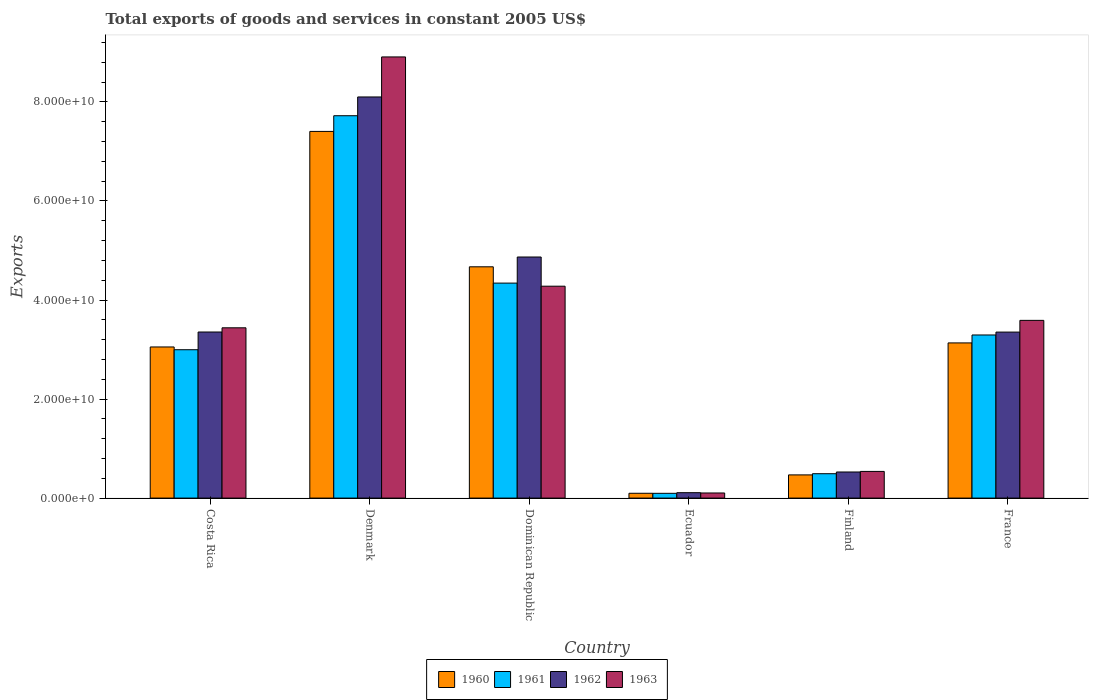How many different coloured bars are there?
Provide a short and direct response. 4. How many groups of bars are there?
Make the answer very short. 6. Are the number of bars per tick equal to the number of legend labels?
Keep it short and to the point. Yes. Are the number of bars on each tick of the X-axis equal?
Offer a very short reply. Yes. How many bars are there on the 4th tick from the left?
Ensure brevity in your answer.  4. What is the label of the 4th group of bars from the left?
Your answer should be very brief. Ecuador. In how many cases, is the number of bars for a given country not equal to the number of legend labels?
Your answer should be very brief. 0. What is the total exports of goods and services in 1963 in Dominican Republic?
Keep it short and to the point. 4.28e+1. Across all countries, what is the maximum total exports of goods and services in 1963?
Your answer should be very brief. 8.91e+1. Across all countries, what is the minimum total exports of goods and services in 1961?
Give a very brief answer. 9.65e+08. In which country was the total exports of goods and services in 1961 maximum?
Provide a short and direct response. Denmark. In which country was the total exports of goods and services in 1960 minimum?
Your response must be concise. Ecuador. What is the total total exports of goods and services in 1962 in the graph?
Keep it short and to the point. 2.03e+11. What is the difference between the total exports of goods and services in 1963 in Costa Rica and that in Denmark?
Make the answer very short. -5.47e+1. What is the difference between the total exports of goods and services in 1962 in Ecuador and the total exports of goods and services in 1963 in France?
Your answer should be very brief. -3.48e+1. What is the average total exports of goods and services in 1960 per country?
Provide a short and direct response. 3.14e+1. What is the difference between the total exports of goods and services of/in 1961 and total exports of goods and services of/in 1962 in Dominican Republic?
Ensure brevity in your answer.  -5.27e+09. What is the ratio of the total exports of goods and services in 1963 in Costa Rica to that in Finland?
Make the answer very short. 6.38. Is the difference between the total exports of goods and services in 1961 in Costa Rica and Denmark greater than the difference between the total exports of goods and services in 1962 in Costa Rica and Denmark?
Offer a very short reply. Yes. What is the difference between the highest and the second highest total exports of goods and services in 1960?
Provide a short and direct response. -2.73e+1. What is the difference between the highest and the lowest total exports of goods and services in 1963?
Ensure brevity in your answer.  8.81e+1. Is it the case that in every country, the sum of the total exports of goods and services in 1961 and total exports of goods and services in 1963 is greater than the sum of total exports of goods and services in 1960 and total exports of goods and services in 1962?
Your answer should be very brief. No. What does the 4th bar from the left in Finland represents?
Provide a succinct answer. 1963. Is it the case that in every country, the sum of the total exports of goods and services in 1962 and total exports of goods and services in 1961 is greater than the total exports of goods and services in 1960?
Ensure brevity in your answer.  Yes. Does the graph contain grids?
Ensure brevity in your answer.  No. How are the legend labels stacked?
Your answer should be compact. Horizontal. What is the title of the graph?
Make the answer very short. Total exports of goods and services in constant 2005 US$. Does "1962" appear as one of the legend labels in the graph?
Your response must be concise. Yes. What is the label or title of the Y-axis?
Provide a succinct answer. Exports. What is the Exports of 1960 in Costa Rica?
Make the answer very short. 3.05e+1. What is the Exports of 1961 in Costa Rica?
Offer a very short reply. 3.00e+1. What is the Exports in 1962 in Costa Rica?
Provide a short and direct response. 3.35e+1. What is the Exports of 1963 in Costa Rica?
Keep it short and to the point. 3.44e+1. What is the Exports of 1960 in Denmark?
Offer a terse response. 7.40e+1. What is the Exports in 1961 in Denmark?
Give a very brief answer. 7.72e+1. What is the Exports of 1962 in Denmark?
Provide a succinct answer. 8.10e+1. What is the Exports in 1963 in Denmark?
Keep it short and to the point. 8.91e+1. What is the Exports in 1960 in Dominican Republic?
Provide a succinct answer. 4.67e+1. What is the Exports in 1961 in Dominican Republic?
Keep it short and to the point. 4.34e+1. What is the Exports in 1962 in Dominican Republic?
Your answer should be compact. 4.87e+1. What is the Exports in 1963 in Dominican Republic?
Make the answer very short. 4.28e+1. What is the Exports of 1960 in Ecuador?
Keep it short and to the point. 9.72e+08. What is the Exports of 1961 in Ecuador?
Your answer should be compact. 9.65e+08. What is the Exports in 1962 in Ecuador?
Your answer should be very brief. 1.09e+09. What is the Exports of 1963 in Ecuador?
Your answer should be compact. 1.03e+09. What is the Exports of 1960 in Finland?
Give a very brief answer. 4.68e+09. What is the Exports in 1961 in Finland?
Your response must be concise. 4.92e+09. What is the Exports of 1962 in Finland?
Provide a short and direct response. 5.27e+09. What is the Exports of 1963 in Finland?
Make the answer very short. 5.39e+09. What is the Exports in 1960 in France?
Your answer should be very brief. 3.13e+1. What is the Exports of 1961 in France?
Your answer should be compact. 3.29e+1. What is the Exports in 1962 in France?
Make the answer very short. 3.35e+1. What is the Exports of 1963 in France?
Provide a succinct answer. 3.59e+1. Across all countries, what is the maximum Exports in 1960?
Make the answer very short. 7.40e+1. Across all countries, what is the maximum Exports of 1961?
Your answer should be very brief. 7.72e+1. Across all countries, what is the maximum Exports of 1962?
Your response must be concise. 8.10e+1. Across all countries, what is the maximum Exports of 1963?
Provide a short and direct response. 8.91e+1. Across all countries, what is the minimum Exports of 1960?
Offer a terse response. 9.72e+08. Across all countries, what is the minimum Exports of 1961?
Make the answer very short. 9.65e+08. Across all countries, what is the minimum Exports in 1962?
Make the answer very short. 1.09e+09. Across all countries, what is the minimum Exports in 1963?
Your answer should be compact. 1.03e+09. What is the total Exports in 1960 in the graph?
Offer a very short reply. 1.88e+11. What is the total Exports in 1961 in the graph?
Give a very brief answer. 1.89e+11. What is the total Exports of 1962 in the graph?
Offer a terse response. 2.03e+11. What is the total Exports of 1963 in the graph?
Keep it short and to the point. 2.09e+11. What is the difference between the Exports in 1960 in Costa Rica and that in Denmark?
Offer a very short reply. -4.35e+1. What is the difference between the Exports in 1961 in Costa Rica and that in Denmark?
Offer a very short reply. -4.73e+1. What is the difference between the Exports of 1962 in Costa Rica and that in Denmark?
Offer a terse response. -4.75e+1. What is the difference between the Exports in 1963 in Costa Rica and that in Denmark?
Give a very brief answer. -5.47e+1. What is the difference between the Exports in 1960 in Costa Rica and that in Dominican Republic?
Make the answer very short. -1.62e+1. What is the difference between the Exports in 1961 in Costa Rica and that in Dominican Republic?
Your answer should be very brief. -1.35e+1. What is the difference between the Exports of 1962 in Costa Rica and that in Dominican Republic?
Offer a terse response. -1.51e+1. What is the difference between the Exports in 1963 in Costa Rica and that in Dominican Republic?
Make the answer very short. -8.40e+09. What is the difference between the Exports in 1960 in Costa Rica and that in Ecuador?
Provide a short and direct response. 2.95e+1. What is the difference between the Exports of 1961 in Costa Rica and that in Ecuador?
Give a very brief answer. 2.90e+1. What is the difference between the Exports of 1962 in Costa Rica and that in Ecuador?
Your response must be concise. 3.24e+1. What is the difference between the Exports in 1963 in Costa Rica and that in Ecuador?
Your answer should be compact. 3.34e+1. What is the difference between the Exports of 1960 in Costa Rica and that in Finland?
Your answer should be compact. 2.58e+1. What is the difference between the Exports of 1961 in Costa Rica and that in Finland?
Ensure brevity in your answer.  2.50e+1. What is the difference between the Exports of 1962 in Costa Rica and that in Finland?
Give a very brief answer. 2.83e+1. What is the difference between the Exports of 1963 in Costa Rica and that in Finland?
Offer a very short reply. 2.90e+1. What is the difference between the Exports in 1960 in Costa Rica and that in France?
Give a very brief answer. -8.16e+08. What is the difference between the Exports in 1961 in Costa Rica and that in France?
Your answer should be very brief. -2.98e+09. What is the difference between the Exports in 1962 in Costa Rica and that in France?
Keep it short and to the point. 1.76e+07. What is the difference between the Exports of 1963 in Costa Rica and that in France?
Offer a terse response. -1.50e+09. What is the difference between the Exports in 1960 in Denmark and that in Dominican Republic?
Your answer should be very brief. 2.73e+1. What is the difference between the Exports in 1961 in Denmark and that in Dominican Republic?
Your response must be concise. 3.38e+1. What is the difference between the Exports in 1962 in Denmark and that in Dominican Republic?
Provide a short and direct response. 3.23e+1. What is the difference between the Exports of 1963 in Denmark and that in Dominican Republic?
Provide a short and direct response. 4.63e+1. What is the difference between the Exports in 1960 in Denmark and that in Ecuador?
Offer a very short reply. 7.31e+1. What is the difference between the Exports of 1961 in Denmark and that in Ecuador?
Provide a succinct answer. 7.62e+1. What is the difference between the Exports in 1962 in Denmark and that in Ecuador?
Make the answer very short. 7.99e+1. What is the difference between the Exports in 1963 in Denmark and that in Ecuador?
Offer a terse response. 8.81e+1. What is the difference between the Exports of 1960 in Denmark and that in Finland?
Offer a terse response. 6.94e+1. What is the difference between the Exports in 1961 in Denmark and that in Finland?
Your answer should be compact. 7.23e+1. What is the difference between the Exports of 1962 in Denmark and that in Finland?
Your answer should be compact. 7.57e+1. What is the difference between the Exports of 1963 in Denmark and that in Finland?
Offer a terse response. 8.37e+1. What is the difference between the Exports in 1960 in Denmark and that in France?
Your response must be concise. 4.27e+1. What is the difference between the Exports in 1961 in Denmark and that in France?
Make the answer very short. 4.43e+1. What is the difference between the Exports of 1962 in Denmark and that in France?
Your answer should be very brief. 4.75e+1. What is the difference between the Exports in 1963 in Denmark and that in France?
Your answer should be very brief. 5.32e+1. What is the difference between the Exports of 1960 in Dominican Republic and that in Ecuador?
Your answer should be compact. 4.57e+1. What is the difference between the Exports in 1961 in Dominican Republic and that in Ecuador?
Offer a terse response. 4.25e+1. What is the difference between the Exports of 1962 in Dominican Republic and that in Ecuador?
Make the answer very short. 4.76e+1. What is the difference between the Exports in 1963 in Dominican Republic and that in Ecuador?
Your response must be concise. 4.18e+1. What is the difference between the Exports in 1960 in Dominican Republic and that in Finland?
Provide a succinct answer. 4.20e+1. What is the difference between the Exports of 1961 in Dominican Republic and that in Finland?
Make the answer very short. 3.85e+1. What is the difference between the Exports in 1962 in Dominican Republic and that in Finland?
Your answer should be very brief. 4.34e+1. What is the difference between the Exports of 1963 in Dominican Republic and that in Finland?
Give a very brief answer. 3.74e+1. What is the difference between the Exports of 1960 in Dominican Republic and that in France?
Provide a succinct answer. 1.54e+1. What is the difference between the Exports of 1961 in Dominican Republic and that in France?
Your answer should be very brief. 1.05e+1. What is the difference between the Exports in 1962 in Dominican Republic and that in France?
Make the answer very short. 1.52e+1. What is the difference between the Exports in 1963 in Dominican Republic and that in France?
Provide a succinct answer. 6.90e+09. What is the difference between the Exports in 1960 in Ecuador and that in Finland?
Offer a very short reply. -3.71e+09. What is the difference between the Exports of 1961 in Ecuador and that in Finland?
Make the answer very short. -3.96e+09. What is the difference between the Exports of 1962 in Ecuador and that in Finland?
Your response must be concise. -4.18e+09. What is the difference between the Exports of 1963 in Ecuador and that in Finland?
Offer a very short reply. -4.36e+09. What is the difference between the Exports of 1960 in Ecuador and that in France?
Your response must be concise. -3.04e+1. What is the difference between the Exports in 1961 in Ecuador and that in France?
Your answer should be compact. -3.20e+1. What is the difference between the Exports in 1962 in Ecuador and that in France?
Ensure brevity in your answer.  -3.24e+1. What is the difference between the Exports of 1963 in Ecuador and that in France?
Provide a short and direct response. -3.49e+1. What is the difference between the Exports of 1960 in Finland and that in France?
Ensure brevity in your answer.  -2.67e+1. What is the difference between the Exports in 1961 in Finland and that in France?
Provide a short and direct response. -2.80e+1. What is the difference between the Exports of 1962 in Finland and that in France?
Keep it short and to the point. -2.83e+1. What is the difference between the Exports in 1963 in Finland and that in France?
Keep it short and to the point. -3.05e+1. What is the difference between the Exports in 1960 in Costa Rica and the Exports in 1961 in Denmark?
Offer a very short reply. -4.67e+1. What is the difference between the Exports in 1960 in Costa Rica and the Exports in 1962 in Denmark?
Keep it short and to the point. -5.05e+1. What is the difference between the Exports of 1960 in Costa Rica and the Exports of 1963 in Denmark?
Your answer should be compact. -5.86e+1. What is the difference between the Exports in 1961 in Costa Rica and the Exports in 1962 in Denmark?
Keep it short and to the point. -5.10e+1. What is the difference between the Exports of 1961 in Costa Rica and the Exports of 1963 in Denmark?
Give a very brief answer. -5.91e+1. What is the difference between the Exports of 1962 in Costa Rica and the Exports of 1963 in Denmark?
Provide a short and direct response. -5.55e+1. What is the difference between the Exports of 1960 in Costa Rica and the Exports of 1961 in Dominican Republic?
Offer a terse response. -1.29e+1. What is the difference between the Exports in 1960 in Costa Rica and the Exports in 1962 in Dominican Republic?
Your response must be concise. -1.82e+1. What is the difference between the Exports in 1960 in Costa Rica and the Exports in 1963 in Dominican Republic?
Provide a succinct answer. -1.23e+1. What is the difference between the Exports of 1961 in Costa Rica and the Exports of 1962 in Dominican Republic?
Offer a very short reply. -1.87e+1. What is the difference between the Exports of 1961 in Costa Rica and the Exports of 1963 in Dominican Republic?
Your response must be concise. -1.28e+1. What is the difference between the Exports of 1962 in Costa Rica and the Exports of 1963 in Dominican Republic?
Your response must be concise. -9.25e+09. What is the difference between the Exports in 1960 in Costa Rica and the Exports in 1961 in Ecuador?
Make the answer very short. 2.96e+1. What is the difference between the Exports of 1960 in Costa Rica and the Exports of 1962 in Ecuador?
Offer a very short reply. 2.94e+1. What is the difference between the Exports in 1960 in Costa Rica and the Exports in 1963 in Ecuador?
Give a very brief answer. 2.95e+1. What is the difference between the Exports of 1961 in Costa Rica and the Exports of 1962 in Ecuador?
Ensure brevity in your answer.  2.89e+1. What is the difference between the Exports of 1961 in Costa Rica and the Exports of 1963 in Ecuador?
Ensure brevity in your answer.  2.89e+1. What is the difference between the Exports of 1962 in Costa Rica and the Exports of 1963 in Ecuador?
Your answer should be compact. 3.25e+1. What is the difference between the Exports in 1960 in Costa Rica and the Exports in 1961 in Finland?
Provide a succinct answer. 2.56e+1. What is the difference between the Exports of 1960 in Costa Rica and the Exports of 1962 in Finland?
Offer a terse response. 2.52e+1. What is the difference between the Exports of 1960 in Costa Rica and the Exports of 1963 in Finland?
Offer a very short reply. 2.51e+1. What is the difference between the Exports in 1961 in Costa Rica and the Exports in 1962 in Finland?
Keep it short and to the point. 2.47e+1. What is the difference between the Exports of 1961 in Costa Rica and the Exports of 1963 in Finland?
Your answer should be compact. 2.46e+1. What is the difference between the Exports of 1962 in Costa Rica and the Exports of 1963 in Finland?
Ensure brevity in your answer.  2.82e+1. What is the difference between the Exports in 1960 in Costa Rica and the Exports in 1961 in France?
Provide a succinct answer. -2.42e+09. What is the difference between the Exports in 1960 in Costa Rica and the Exports in 1962 in France?
Provide a succinct answer. -3.00e+09. What is the difference between the Exports in 1960 in Costa Rica and the Exports in 1963 in France?
Offer a terse response. -5.37e+09. What is the difference between the Exports in 1961 in Costa Rica and the Exports in 1962 in France?
Your answer should be very brief. -3.56e+09. What is the difference between the Exports in 1961 in Costa Rica and the Exports in 1963 in France?
Your answer should be very brief. -5.93e+09. What is the difference between the Exports in 1962 in Costa Rica and the Exports in 1963 in France?
Offer a very short reply. -2.35e+09. What is the difference between the Exports of 1960 in Denmark and the Exports of 1961 in Dominican Republic?
Keep it short and to the point. 3.06e+1. What is the difference between the Exports of 1960 in Denmark and the Exports of 1962 in Dominican Republic?
Give a very brief answer. 2.54e+1. What is the difference between the Exports of 1960 in Denmark and the Exports of 1963 in Dominican Republic?
Offer a terse response. 3.13e+1. What is the difference between the Exports in 1961 in Denmark and the Exports in 1962 in Dominican Republic?
Provide a succinct answer. 2.85e+1. What is the difference between the Exports in 1961 in Denmark and the Exports in 1963 in Dominican Republic?
Offer a terse response. 3.44e+1. What is the difference between the Exports of 1962 in Denmark and the Exports of 1963 in Dominican Republic?
Your answer should be very brief. 3.82e+1. What is the difference between the Exports of 1960 in Denmark and the Exports of 1961 in Ecuador?
Ensure brevity in your answer.  7.31e+1. What is the difference between the Exports of 1960 in Denmark and the Exports of 1962 in Ecuador?
Ensure brevity in your answer.  7.30e+1. What is the difference between the Exports of 1960 in Denmark and the Exports of 1963 in Ecuador?
Give a very brief answer. 7.30e+1. What is the difference between the Exports of 1961 in Denmark and the Exports of 1962 in Ecuador?
Keep it short and to the point. 7.61e+1. What is the difference between the Exports of 1961 in Denmark and the Exports of 1963 in Ecuador?
Keep it short and to the point. 7.62e+1. What is the difference between the Exports of 1962 in Denmark and the Exports of 1963 in Ecuador?
Provide a succinct answer. 8.00e+1. What is the difference between the Exports of 1960 in Denmark and the Exports of 1961 in Finland?
Provide a short and direct response. 6.91e+1. What is the difference between the Exports of 1960 in Denmark and the Exports of 1962 in Finland?
Your answer should be very brief. 6.88e+1. What is the difference between the Exports of 1960 in Denmark and the Exports of 1963 in Finland?
Your answer should be compact. 6.87e+1. What is the difference between the Exports of 1961 in Denmark and the Exports of 1962 in Finland?
Provide a short and direct response. 7.19e+1. What is the difference between the Exports in 1961 in Denmark and the Exports in 1963 in Finland?
Provide a short and direct response. 7.18e+1. What is the difference between the Exports of 1962 in Denmark and the Exports of 1963 in Finland?
Provide a short and direct response. 7.56e+1. What is the difference between the Exports in 1960 in Denmark and the Exports in 1961 in France?
Provide a succinct answer. 4.11e+1. What is the difference between the Exports in 1960 in Denmark and the Exports in 1962 in France?
Your answer should be compact. 4.05e+1. What is the difference between the Exports in 1960 in Denmark and the Exports in 1963 in France?
Offer a terse response. 3.82e+1. What is the difference between the Exports of 1961 in Denmark and the Exports of 1962 in France?
Offer a very short reply. 4.37e+1. What is the difference between the Exports in 1961 in Denmark and the Exports in 1963 in France?
Offer a terse response. 4.13e+1. What is the difference between the Exports in 1962 in Denmark and the Exports in 1963 in France?
Offer a terse response. 4.51e+1. What is the difference between the Exports in 1960 in Dominican Republic and the Exports in 1961 in Ecuador?
Provide a succinct answer. 4.57e+1. What is the difference between the Exports in 1960 in Dominican Republic and the Exports in 1962 in Ecuador?
Provide a short and direct response. 4.56e+1. What is the difference between the Exports of 1960 in Dominican Republic and the Exports of 1963 in Ecuador?
Ensure brevity in your answer.  4.57e+1. What is the difference between the Exports of 1961 in Dominican Republic and the Exports of 1962 in Ecuador?
Your answer should be compact. 4.23e+1. What is the difference between the Exports in 1961 in Dominican Republic and the Exports in 1963 in Ecuador?
Make the answer very short. 4.24e+1. What is the difference between the Exports in 1962 in Dominican Republic and the Exports in 1963 in Ecuador?
Offer a very short reply. 4.77e+1. What is the difference between the Exports of 1960 in Dominican Republic and the Exports of 1961 in Finland?
Keep it short and to the point. 4.18e+1. What is the difference between the Exports in 1960 in Dominican Republic and the Exports in 1962 in Finland?
Your answer should be very brief. 4.14e+1. What is the difference between the Exports of 1960 in Dominican Republic and the Exports of 1963 in Finland?
Provide a succinct answer. 4.13e+1. What is the difference between the Exports in 1961 in Dominican Republic and the Exports in 1962 in Finland?
Make the answer very short. 3.81e+1. What is the difference between the Exports of 1961 in Dominican Republic and the Exports of 1963 in Finland?
Keep it short and to the point. 3.80e+1. What is the difference between the Exports in 1962 in Dominican Republic and the Exports in 1963 in Finland?
Keep it short and to the point. 4.33e+1. What is the difference between the Exports in 1960 in Dominican Republic and the Exports in 1961 in France?
Provide a short and direct response. 1.38e+1. What is the difference between the Exports in 1960 in Dominican Republic and the Exports in 1962 in France?
Keep it short and to the point. 1.32e+1. What is the difference between the Exports of 1960 in Dominican Republic and the Exports of 1963 in France?
Give a very brief answer. 1.08e+1. What is the difference between the Exports of 1961 in Dominican Republic and the Exports of 1962 in France?
Provide a succinct answer. 9.89e+09. What is the difference between the Exports in 1961 in Dominican Republic and the Exports in 1963 in France?
Your response must be concise. 7.53e+09. What is the difference between the Exports in 1962 in Dominican Republic and the Exports in 1963 in France?
Your response must be concise. 1.28e+1. What is the difference between the Exports of 1960 in Ecuador and the Exports of 1961 in Finland?
Provide a succinct answer. -3.95e+09. What is the difference between the Exports of 1960 in Ecuador and the Exports of 1962 in Finland?
Make the answer very short. -4.30e+09. What is the difference between the Exports in 1960 in Ecuador and the Exports in 1963 in Finland?
Keep it short and to the point. -4.41e+09. What is the difference between the Exports in 1961 in Ecuador and the Exports in 1962 in Finland?
Make the answer very short. -4.31e+09. What is the difference between the Exports in 1961 in Ecuador and the Exports in 1963 in Finland?
Provide a short and direct response. -4.42e+09. What is the difference between the Exports in 1962 in Ecuador and the Exports in 1963 in Finland?
Give a very brief answer. -4.29e+09. What is the difference between the Exports in 1960 in Ecuador and the Exports in 1961 in France?
Your response must be concise. -3.20e+1. What is the difference between the Exports of 1960 in Ecuador and the Exports of 1962 in France?
Offer a very short reply. -3.25e+1. What is the difference between the Exports in 1960 in Ecuador and the Exports in 1963 in France?
Keep it short and to the point. -3.49e+1. What is the difference between the Exports in 1961 in Ecuador and the Exports in 1962 in France?
Offer a very short reply. -3.26e+1. What is the difference between the Exports in 1961 in Ecuador and the Exports in 1963 in France?
Your response must be concise. -3.49e+1. What is the difference between the Exports in 1962 in Ecuador and the Exports in 1963 in France?
Keep it short and to the point. -3.48e+1. What is the difference between the Exports in 1960 in Finland and the Exports in 1961 in France?
Offer a terse response. -2.83e+1. What is the difference between the Exports in 1960 in Finland and the Exports in 1962 in France?
Provide a short and direct response. -2.88e+1. What is the difference between the Exports in 1960 in Finland and the Exports in 1963 in France?
Make the answer very short. -3.12e+1. What is the difference between the Exports of 1961 in Finland and the Exports of 1962 in France?
Your answer should be compact. -2.86e+1. What is the difference between the Exports in 1961 in Finland and the Exports in 1963 in France?
Provide a succinct answer. -3.10e+1. What is the difference between the Exports of 1962 in Finland and the Exports of 1963 in France?
Give a very brief answer. -3.06e+1. What is the average Exports in 1960 per country?
Offer a very short reply. 3.14e+1. What is the average Exports in 1961 per country?
Your answer should be very brief. 3.16e+1. What is the average Exports in 1962 per country?
Your response must be concise. 3.39e+1. What is the average Exports of 1963 per country?
Your response must be concise. 3.48e+1. What is the difference between the Exports in 1960 and Exports in 1961 in Costa Rica?
Your response must be concise. 5.60e+08. What is the difference between the Exports in 1960 and Exports in 1962 in Costa Rica?
Your answer should be compact. -3.02e+09. What is the difference between the Exports in 1960 and Exports in 1963 in Costa Rica?
Keep it short and to the point. -3.87e+09. What is the difference between the Exports in 1961 and Exports in 1962 in Costa Rica?
Make the answer very short. -3.58e+09. What is the difference between the Exports of 1961 and Exports of 1963 in Costa Rica?
Keep it short and to the point. -4.43e+09. What is the difference between the Exports in 1962 and Exports in 1963 in Costa Rica?
Give a very brief answer. -8.49e+08. What is the difference between the Exports in 1960 and Exports in 1961 in Denmark?
Your answer should be very brief. -3.17e+09. What is the difference between the Exports in 1960 and Exports in 1962 in Denmark?
Provide a succinct answer. -6.96e+09. What is the difference between the Exports of 1960 and Exports of 1963 in Denmark?
Your answer should be compact. -1.50e+1. What is the difference between the Exports of 1961 and Exports of 1962 in Denmark?
Make the answer very short. -3.79e+09. What is the difference between the Exports of 1961 and Exports of 1963 in Denmark?
Give a very brief answer. -1.19e+1. What is the difference between the Exports in 1962 and Exports in 1963 in Denmark?
Keep it short and to the point. -8.08e+09. What is the difference between the Exports in 1960 and Exports in 1961 in Dominican Republic?
Ensure brevity in your answer.  3.29e+09. What is the difference between the Exports of 1960 and Exports of 1962 in Dominican Republic?
Keep it short and to the point. -1.98e+09. What is the difference between the Exports of 1960 and Exports of 1963 in Dominican Republic?
Ensure brevity in your answer.  3.92e+09. What is the difference between the Exports of 1961 and Exports of 1962 in Dominican Republic?
Offer a very short reply. -5.27e+09. What is the difference between the Exports of 1961 and Exports of 1963 in Dominican Republic?
Ensure brevity in your answer.  6.26e+08. What is the difference between the Exports of 1962 and Exports of 1963 in Dominican Republic?
Your answer should be compact. 5.89e+09. What is the difference between the Exports of 1960 and Exports of 1961 in Ecuador?
Offer a terse response. 7.18e+06. What is the difference between the Exports in 1960 and Exports in 1962 in Ecuador?
Ensure brevity in your answer.  -1.22e+08. What is the difference between the Exports in 1960 and Exports in 1963 in Ecuador?
Give a very brief answer. -5.99e+07. What is the difference between the Exports of 1961 and Exports of 1962 in Ecuador?
Offer a terse response. -1.29e+08. What is the difference between the Exports in 1961 and Exports in 1963 in Ecuador?
Offer a terse response. -6.70e+07. What is the difference between the Exports of 1962 and Exports of 1963 in Ecuador?
Offer a terse response. 6.23e+07. What is the difference between the Exports of 1960 and Exports of 1961 in Finland?
Your answer should be very brief. -2.41e+08. What is the difference between the Exports in 1960 and Exports in 1962 in Finland?
Provide a succinct answer. -5.89e+08. What is the difference between the Exports in 1960 and Exports in 1963 in Finland?
Give a very brief answer. -7.04e+08. What is the difference between the Exports of 1961 and Exports of 1962 in Finland?
Offer a terse response. -3.48e+08. What is the difference between the Exports in 1961 and Exports in 1963 in Finland?
Your response must be concise. -4.64e+08. What is the difference between the Exports of 1962 and Exports of 1963 in Finland?
Provide a short and direct response. -1.15e+08. What is the difference between the Exports of 1960 and Exports of 1961 in France?
Your response must be concise. -1.60e+09. What is the difference between the Exports of 1960 and Exports of 1962 in France?
Give a very brief answer. -2.19e+09. What is the difference between the Exports in 1960 and Exports in 1963 in France?
Keep it short and to the point. -4.55e+09. What is the difference between the Exports of 1961 and Exports of 1962 in France?
Make the answer very short. -5.82e+08. What is the difference between the Exports in 1961 and Exports in 1963 in France?
Ensure brevity in your answer.  -2.95e+09. What is the difference between the Exports of 1962 and Exports of 1963 in France?
Provide a short and direct response. -2.37e+09. What is the ratio of the Exports in 1960 in Costa Rica to that in Denmark?
Make the answer very short. 0.41. What is the ratio of the Exports in 1961 in Costa Rica to that in Denmark?
Ensure brevity in your answer.  0.39. What is the ratio of the Exports in 1962 in Costa Rica to that in Denmark?
Ensure brevity in your answer.  0.41. What is the ratio of the Exports in 1963 in Costa Rica to that in Denmark?
Keep it short and to the point. 0.39. What is the ratio of the Exports of 1960 in Costa Rica to that in Dominican Republic?
Offer a terse response. 0.65. What is the ratio of the Exports in 1961 in Costa Rica to that in Dominican Republic?
Ensure brevity in your answer.  0.69. What is the ratio of the Exports of 1962 in Costa Rica to that in Dominican Republic?
Your response must be concise. 0.69. What is the ratio of the Exports of 1963 in Costa Rica to that in Dominican Republic?
Keep it short and to the point. 0.8. What is the ratio of the Exports of 1960 in Costa Rica to that in Ecuador?
Provide a succinct answer. 31.39. What is the ratio of the Exports of 1961 in Costa Rica to that in Ecuador?
Your answer should be very brief. 31.05. What is the ratio of the Exports in 1962 in Costa Rica to that in Ecuador?
Give a very brief answer. 30.65. What is the ratio of the Exports of 1963 in Costa Rica to that in Ecuador?
Your answer should be compact. 33.32. What is the ratio of the Exports in 1960 in Costa Rica to that in Finland?
Give a very brief answer. 6.52. What is the ratio of the Exports in 1961 in Costa Rica to that in Finland?
Provide a short and direct response. 6.08. What is the ratio of the Exports of 1962 in Costa Rica to that in Finland?
Offer a terse response. 6.36. What is the ratio of the Exports in 1963 in Costa Rica to that in Finland?
Provide a succinct answer. 6.38. What is the ratio of the Exports in 1960 in Costa Rica to that in France?
Offer a very short reply. 0.97. What is the ratio of the Exports in 1961 in Costa Rica to that in France?
Your answer should be very brief. 0.91. What is the ratio of the Exports in 1963 in Costa Rica to that in France?
Provide a succinct answer. 0.96. What is the ratio of the Exports in 1960 in Denmark to that in Dominican Republic?
Your response must be concise. 1.59. What is the ratio of the Exports of 1961 in Denmark to that in Dominican Republic?
Offer a very short reply. 1.78. What is the ratio of the Exports in 1962 in Denmark to that in Dominican Republic?
Provide a short and direct response. 1.66. What is the ratio of the Exports in 1963 in Denmark to that in Dominican Republic?
Provide a succinct answer. 2.08. What is the ratio of the Exports in 1960 in Denmark to that in Ecuador?
Keep it short and to the point. 76.17. What is the ratio of the Exports in 1961 in Denmark to that in Ecuador?
Give a very brief answer. 80.01. What is the ratio of the Exports in 1962 in Denmark to that in Ecuador?
Offer a very short reply. 74.02. What is the ratio of the Exports in 1963 in Denmark to that in Ecuador?
Give a very brief answer. 86.32. What is the ratio of the Exports in 1960 in Denmark to that in Finland?
Give a very brief answer. 15.81. What is the ratio of the Exports of 1961 in Denmark to that in Finland?
Provide a short and direct response. 15.68. What is the ratio of the Exports of 1962 in Denmark to that in Finland?
Your answer should be compact. 15.37. What is the ratio of the Exports in 1963 in Denmark to that in Finland?
Your answer should be very brief. 16.54. What is the ratio of the Exports of 1960 in Denmark to that in France?
Your response must be concise. 2.36. What is the ratio of the Exports of 1961 in Denmark to that in France?
Provide a succinct answer. 2.34. What is the ratio of the Exports in 1962 in Denmark to that in France?
Your answer should be compact. 2.42. What is the ratio of the Exports in 1963 in Denmark to that in France?
Provide a short and direct response. 2.48. What is the ratio of the Exports in 1960 in Dominican Republic to that in Ecuador?
Make the answer very short. 48.04. What is the ratio of the Exports in 1961 in Dominican Republic to that in Ecuador?
Ensure brevity in your answer.  44.99. What is the ratio of the Exports of 1962 in Dominican Republic to that in Ecuador?
Your answer should be very brief. 44.49. What is the ratio of the Exports in 1963 in Dominican Republic to that in Ecuador?
Make the answer very short. 41.46. What is the ratio of the Exports of 1960 in Dominican Republic to that in Finland?
Make the answer very short. 9.97. What is the ratio of the Exports in 1961 in Dominican Republic to that in Finland?
Keep it short and to the point. 8.82. What is the ratio of the Exports of 1962 in Dominican Republic to that in Finland?
Keep it short and to the point. 9.23. What is the ratio of the Exports of 1963 in Dominican Republic to that in Finland?
Your answer should be very brief. 7.94. What is the ratio of the Exports in 1960 in Dominican Republic to that in France?
Your response must be concise. 1.49. What is the ratio of the Exports of 1961 in Dominican Republic to that in France?
Your answer should be compact. 1.32. What is the ratio of the Exports of 1962 in Dominican Republic to that in France?
Offer a very short reply. 1.45. What is the ratio of the Exports in 1963 in Dominican Republic to that in France?
Give a very brief answer. 1.19. What is the ratio of the Exports of 1960 in Ecuador to that in Finland?
Provide a short and direct response. 0.21. What is the ratio of the Exports in 1961 in Ecuador to that in Finland?
Provide a short and direct response. 0.2. What is the ratio of the Exports in 1962 in Ecuador to that in Finland?
Offer a very short reply. 0.21. What is the ratio of the Exports in 1963 in Ecuador to that in Finland?
Offer a very short reply. 0.19. What is the ratio of the Exports of 1960 in Ecuador to that in France?
Provide a succinct answer. 0.03. What is the ratio of the Exports of 1961 in Ecuador to that in France?
Give a very brief answer. 0.03. What is the ratio of the Exports of 1962 in Ecuador to that in France?
Offer a terse response. 0.03. What is the ratio of the Exports in 1963 in Ecuador to that in France?
Your answer should be very brief. 0.03. What is the ratio of the Exports in 1960 in Finland to that in France?
Provide a short and direct response. 0.15. What is the ratio of the Exports in 1961 in Finland to that in France?
Give a very brief answer. 0.15. What is the ratio of the Exports in 1962 in Finland to that in France?
Ensure brevity in your answer.  0.16. What is the ratio of the Exports in 1963 in Finland to that in France?
Give a very brief answer. 0.15. What is the difference between the highest and the second highest Exports of 1960?
Give a very brief answer. 2.73e+1. What is the difference between the highest and the second highest Exports in 1961?
Offer a terse response. 3.38e+1. What is the difference between the highest and the second highest Exports in 1962?
Ensure brevity in your answer.  3.23e+1. What is the difference between the highest and the second highest Exports of 1963?
Provide a short and direct response. 4.63e+1. What is the difference between the highest and the lowest Exports of 1960?
Provide a succinct answer. 7.31e+1. What is the difference between the highest and the lowest Exports in 1961?
Your answer should be very brief. 7.62e+1. What is the difference between the highest and the lowest Exports in 1962?
Your response must be concise. 7.99e+1. What is the difference between the highest and the lowest Exports of 1963?
Offer a terse response. 8.81e+1. 